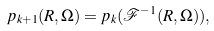Convert formula to latex. <formula><loc_0><loc_0><loc_500><loc_500>p _ { k + 1 } ( R , \Omega ) = p _ { k } ( \mathcal { F } ^ { - 1 } ( R , \Omega ) ) ,</formula> 